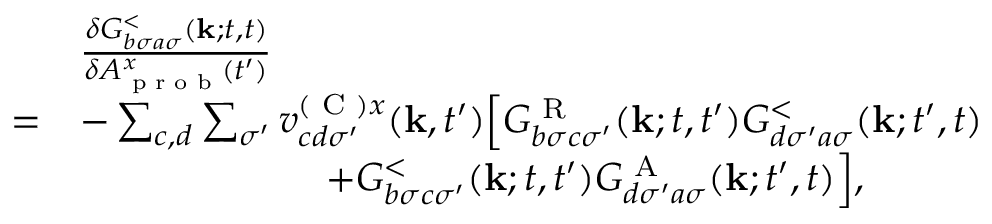Convert formula to latex. <formula><loc_0><loc_0><loc_500><loc_500>\begin{array} { r l } & { \frac { \delta G _ { b \sigma a \sigma } ^ { < } ( k ; t , t ) } { \delta A _ { p r o b } ^ { x } ( t ^ { \prime } ) } } \\ { = } & { - \sum _ { c , d } \sum _ { \sigma ^ { \prime } } v _ { c d \sigma ^ { \prime } } ^ { ( C ) x } ( k , t ^ { \prime } ) \left [ G _ { b \sigma c \sigma ^ { \prime } } ^ { R } ( k ; t , t ^ { \prime } ) G _ { d \sigma ^ { \prime } a \sigma } ^ { < } ( k ; t ^ { \prime } , t ) } \\ & { \quad + G _ { b \sigma c \sigma ^ { \prime } } ^ { < } ( k ; t , t ^ { \prime } ) G _ { d \sigma ^ { \prime } a \sigma } ^ { A } ( k ; t ^ { \prime } , t ) \right ] , } \end{array}</formula> 